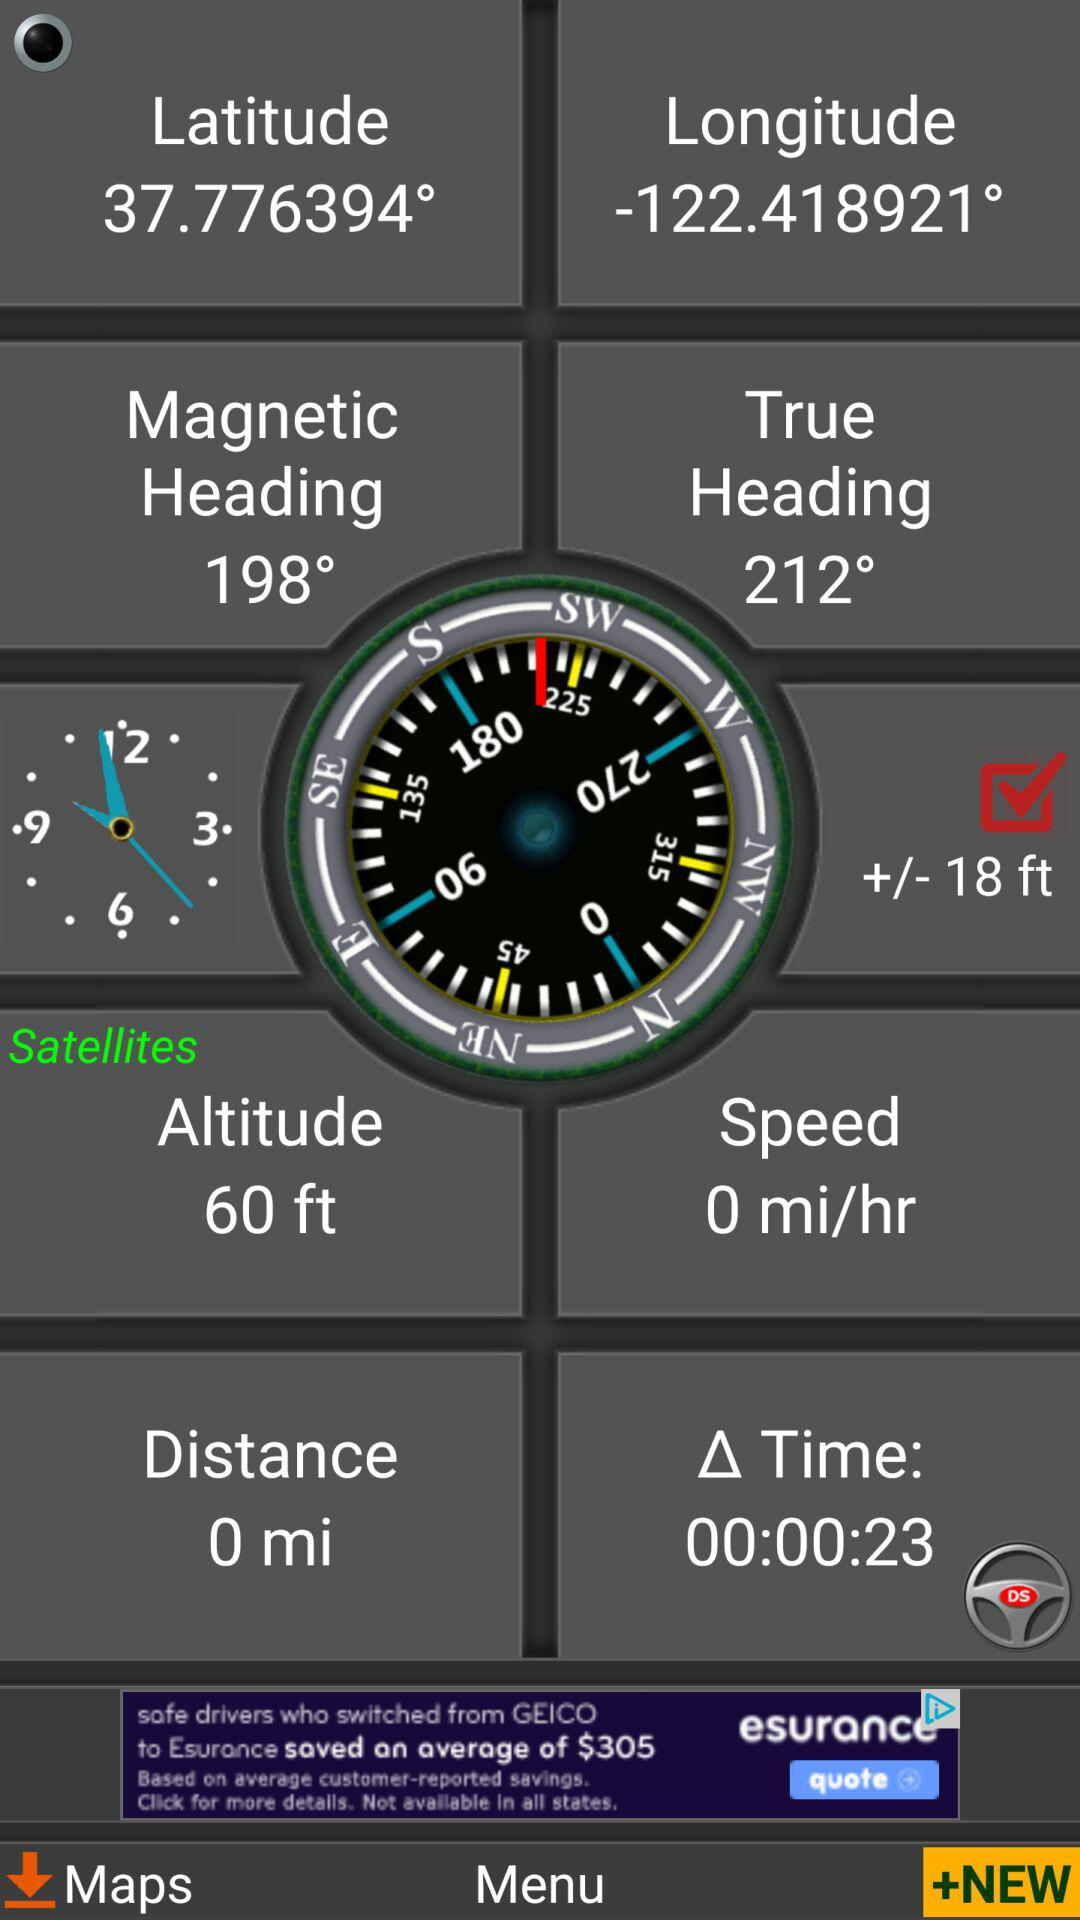How many degrees is the difference between the magnetic heading and the true heading?
Answer the question using a single word or phrase. 14° 